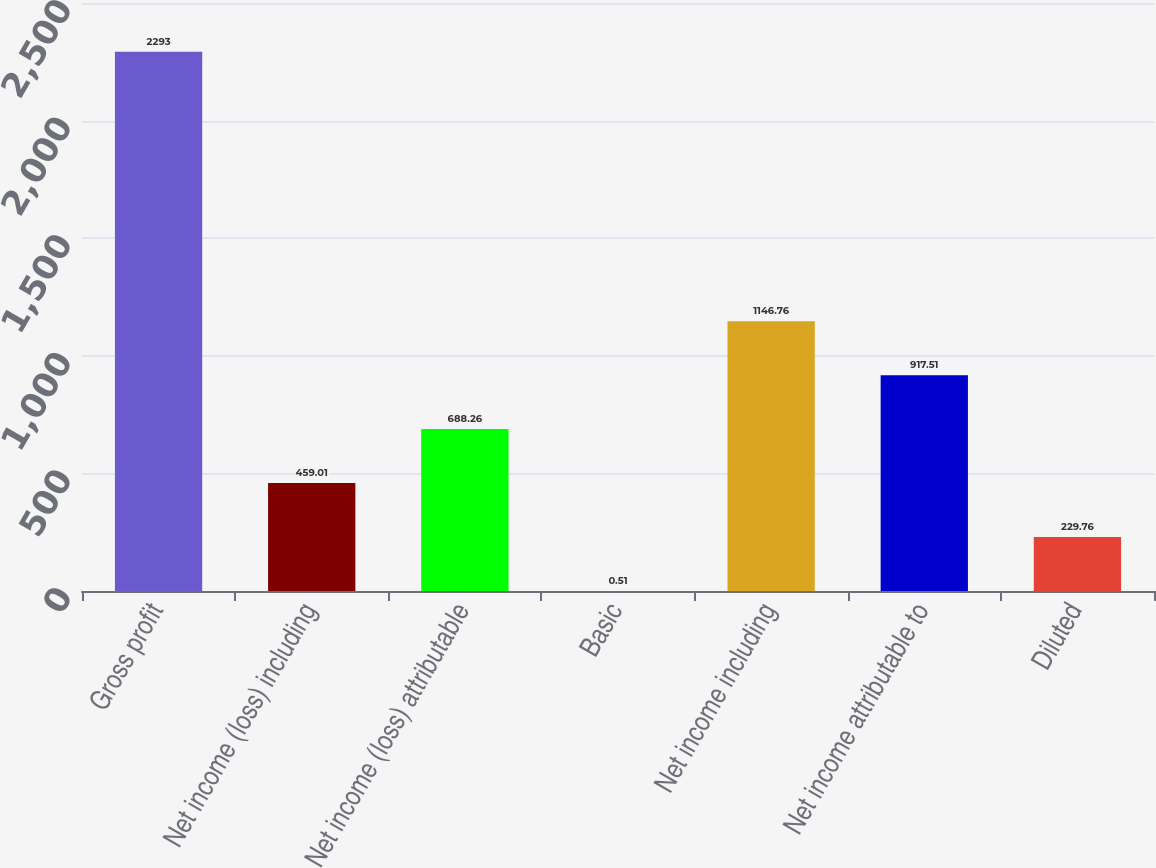<chart> <loc_0><loc_0><loc_500><loc_500><bar_chart><fcel>Gross profit<fcel>Net income (loss) including<fcel>Net income (loss) attributable<fcel>Basic<fcel>Net income including<fcel>Net income attributable to<fcel>Diluted<nl><fcel>2293<fcel>459.01<fcel>688.26<fcel>0.51<fcel>1146.76<fcel>917.51<fcel>229.76<nl></chart> 